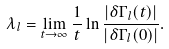<formula> <loc_0><loc_0><loc_500><loc_500>\lambda _ { l } = \lim _ { t \to \infty } \frac { 1 } { t } \ln \frac { | \delta { \Gamma } _ { l } ( t ) | } { | \delta { \Gamma } _ { l } ( 0 ) | } .</formula> 